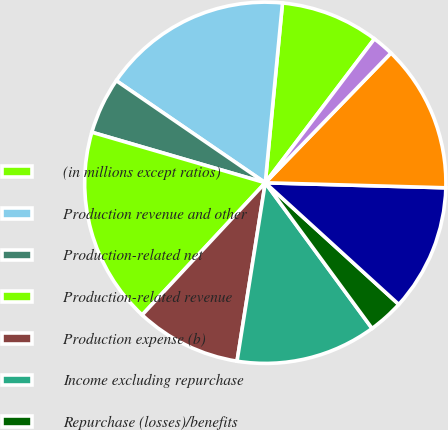Convert chart to OTSL. <chart><loc_0><loc_0><loc_500><loc_500><pie_chart><fcel>(in millions except ratios)<fcel>Production revenue and other<fcel>Production-related net<fcel>Production-related revenue<fcel>Production expense (b)<fcel>Income excluding repurchase<fcel>Repurchase (losses)/benefits<fcel>Income before income tax<fcel>Loan servicing revenue and<fcel>Servicing-related net interest<nl><fcel>8.81%<fcel>16.96%<fcel>5.05%<fcel>17.58%<fcel>9.44%<fcel>12.57%<fcel>3.17%<fcel>11.32%<fcel>13.2%<fcel>1.92%<nl></chart> 